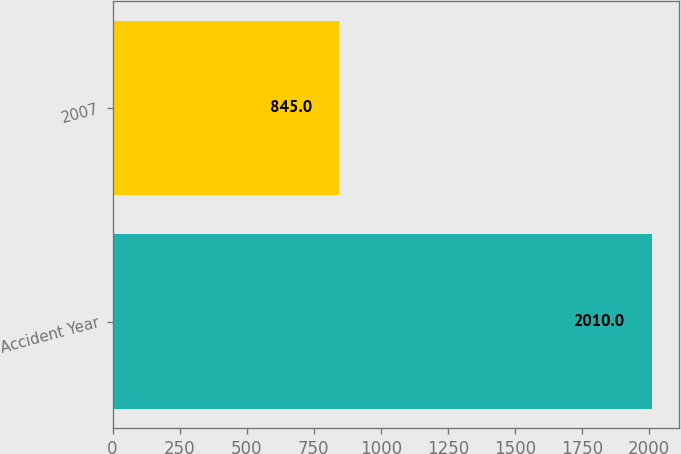Convert chart to OTSL. <chart><loc_0><loc_0><loc_500><loc_500><bar_chart><fcel>Accident Year<fcel>2007<nl><fcel>2010<fcel>845<nl></chart> 